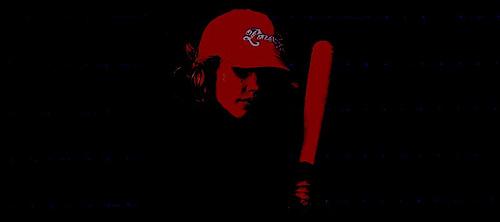Why is the person's coloring strange?
Answer briefly. Special effect. What color is the hat?
Write a very short answer. Red. What is the person holding?
Write a very short answer. Bat. Is the person a man or a woman?
Short answer required. Woman. 